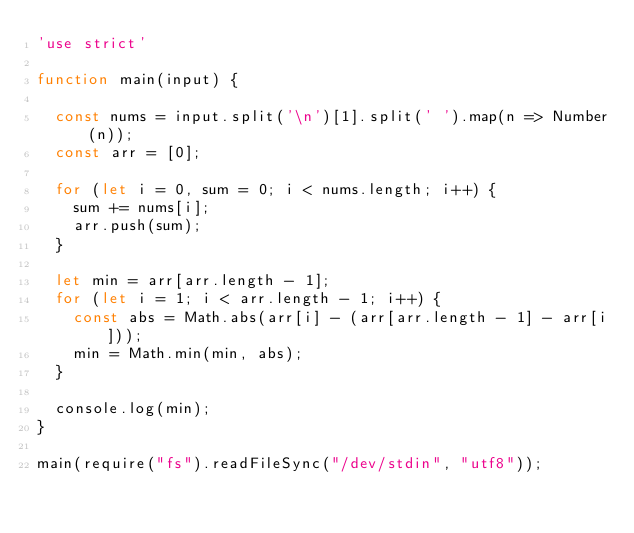Convert code to text. <code><loc_0><loc_0><loc_500><loc_500><_JavaScript_>'use strict'

function main(input) {

  const nums = input.split('\n')[1].split(' ').map(n => Number(n));
  const arr = [0];

  for (let i = 0, sum = 0; i < nums.length; i++) {
    sum += nums[i];
    arr.push(sum);
  }

  let min = arr[arr.length - 1];
  for (let i = 1; i < arr.length - 1; i++) {
    const abs = Math.abs(arr[i] - (arr[arr.length - 1] - arr[i]));
    min = Math.min(min, abs);
  }

  console.log(min);
}

main(require("fs").readFileSync("/dev/stdin", "utf8"));
</code> 